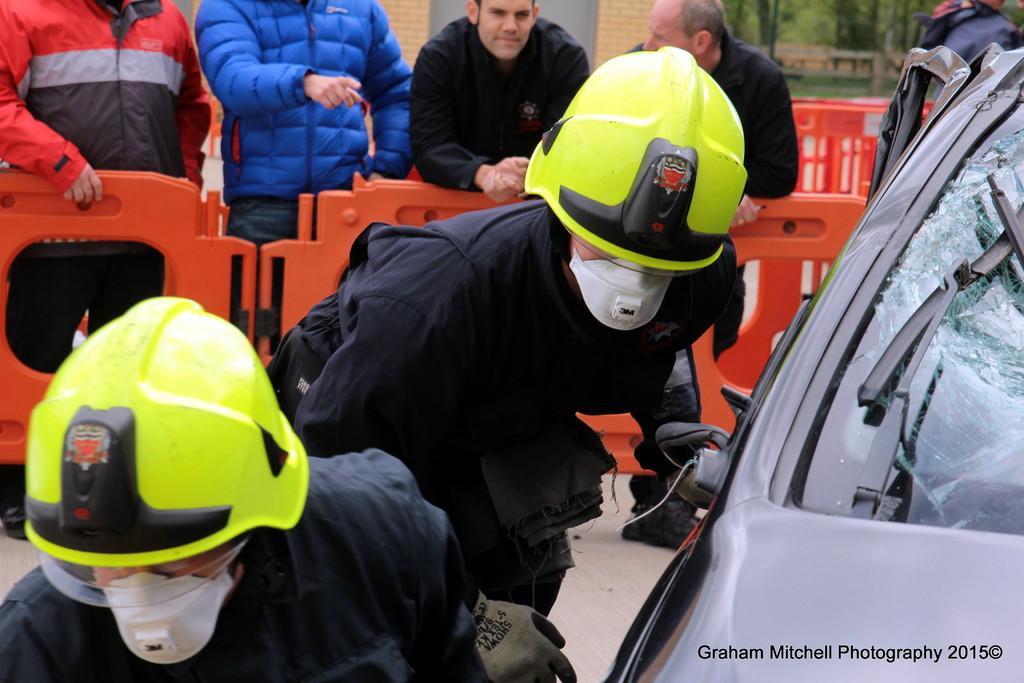Can you describe this image briefly? There are two people wore helmets and masks, in front of these people we can see car. In the background we can see people, red color objects, wall and trees. In the bottom right side of the image we can see text. 